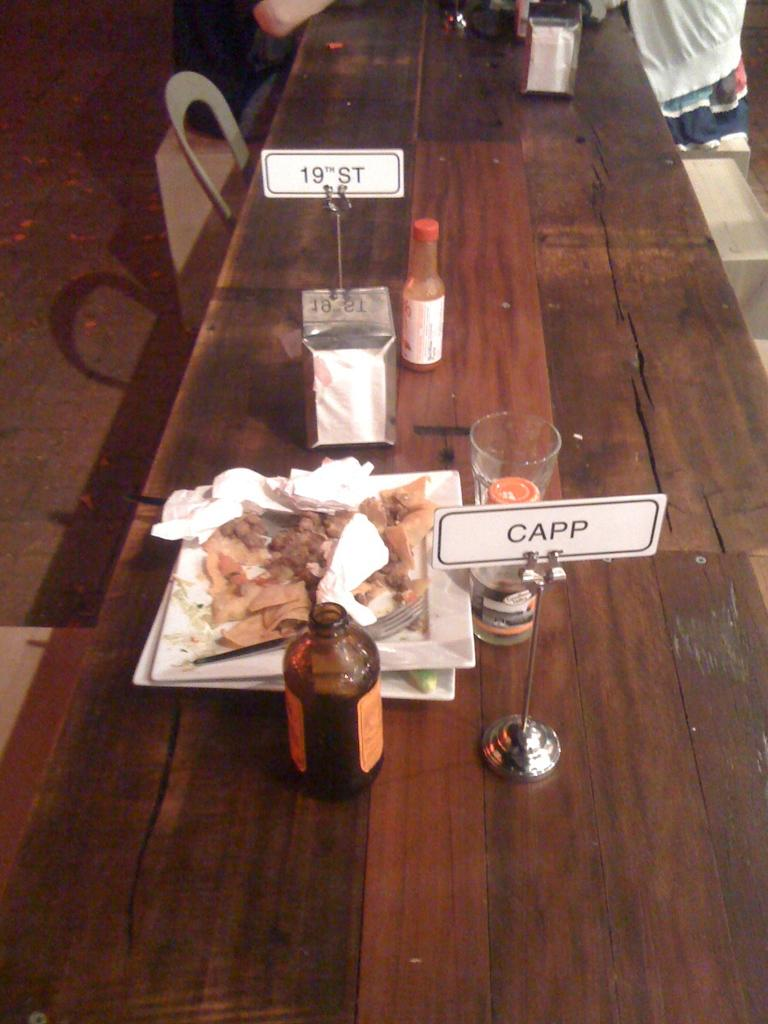<image>
Offer a succinct explanation of the picture presented. A sign for CAPP sits next to uneaten food 